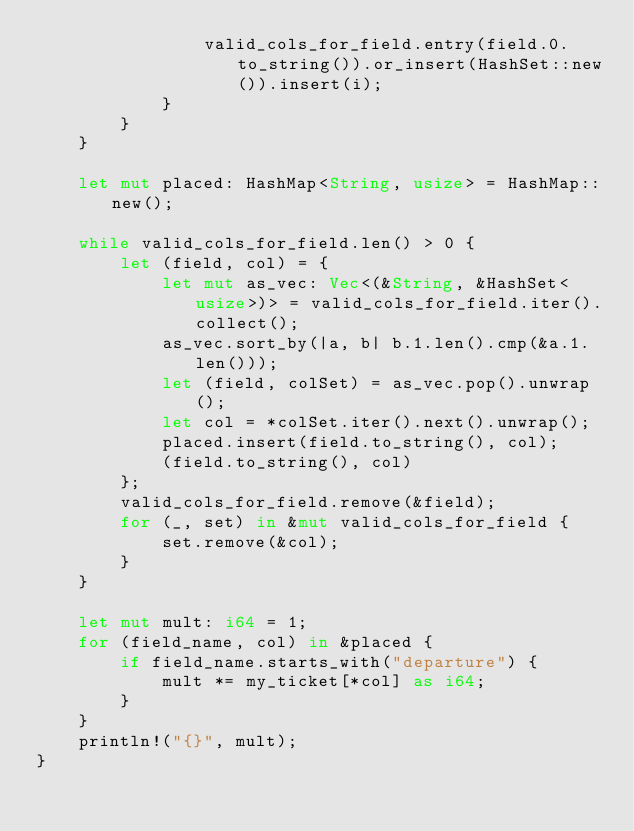<code> <loc_0><loc_0><loc_500><loc_500><_Rust_>                valid_cols_for_field.entry(field.0.to_string()).or_insert(HashSet::new()).insert(i);
            }
        }
    }

    let mut placed: HashMap<String, usize> = HashMap::new();

    while valid_cols_for_field.len() > 0 {
        let (field, col) = {
            let mut as_vec: Vec<(&String, &HashSet<usize>)> = valid_cols_for_field.iter().collect();
            as_vec.sort_by(|a, b| b.1.len().cmp(&a.1.len()));
            let (field, colSet) = as_vec.pop().unwrap();
            let col = *colSet.iter().next().unwrap();
            placed.insert(field.to_string(), col);
            (field.to_string(), col)
        };
        valid_cols_for_field.remove(&field);
        for (_, set) in &mut valid_cols_for_field {
            set.remove(&col);
        }
    }

    let mut mult: i64 = 1;
    for (field_name, col) in &placed {
        if field_name.starts_with("departure") {
            mult *= my_ticket[*col] as i64;
        }
    }
    println!("{}", mult);
}
</code> 